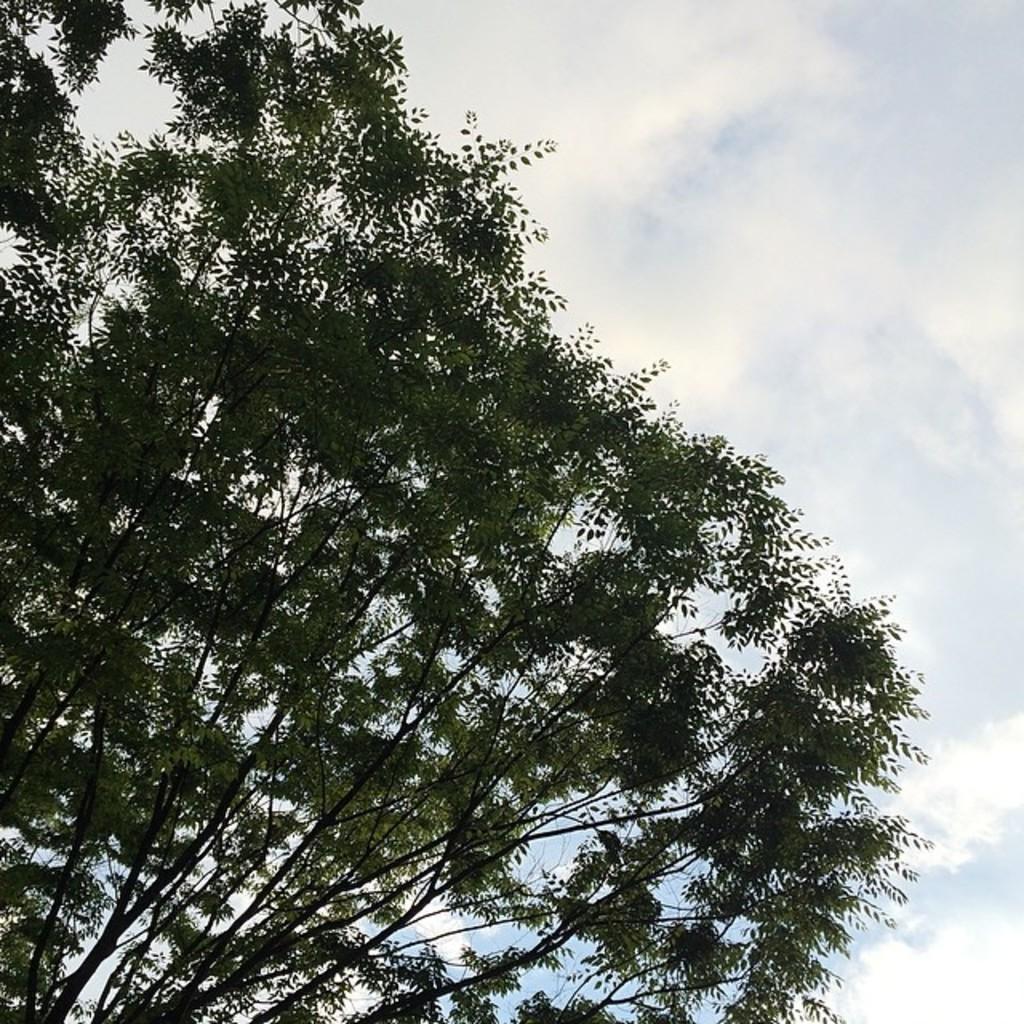Can you describe this image briefly? There is a tree. Behind that there is sky on the top. 